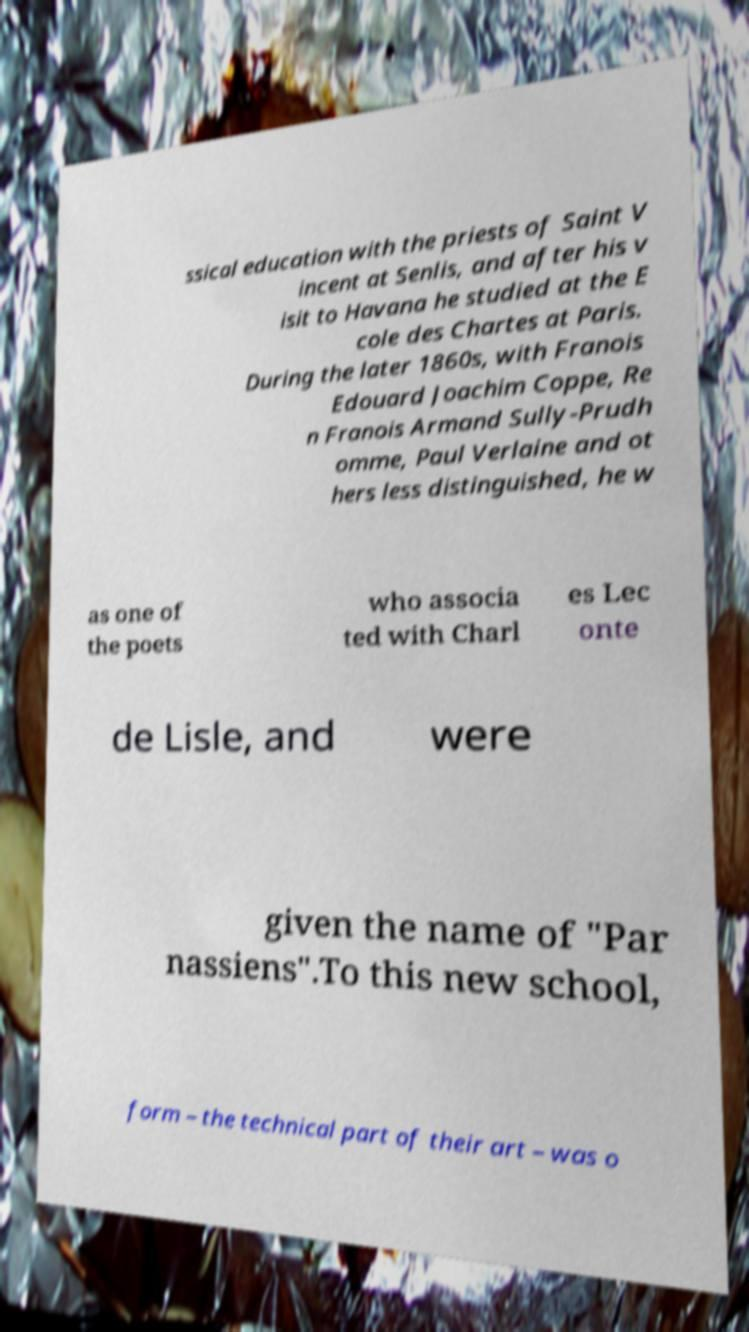Can you accurately transcribe the text from the provided image for me? ssical education with the priests of Saint V incent at Senlis, and after his v isit to Havana he studied at the E cole des Chartes at Paris. During the later 1860s, with Franois Edouard Joachim Coppe, Re n Franois Armand Sully-Prudh omme, Paul Verlaine and ot hers less distinguished, he w as one of the poets who associa ted with Charl es Lec onte de Lisle, and were given the name of "Par nassiens".To this new school, form – the technical part of their art – was o 